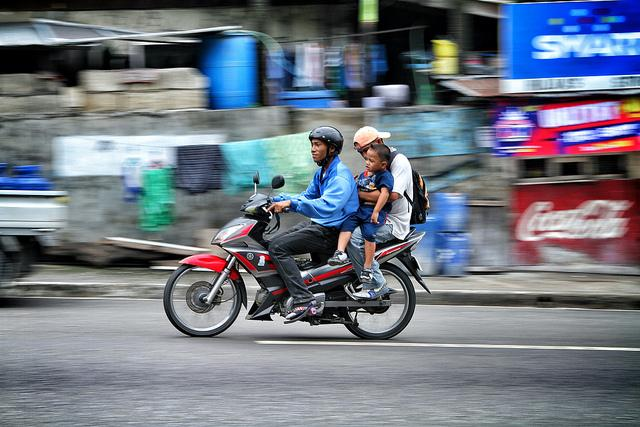What year was Coca-Cola founded? 1892 